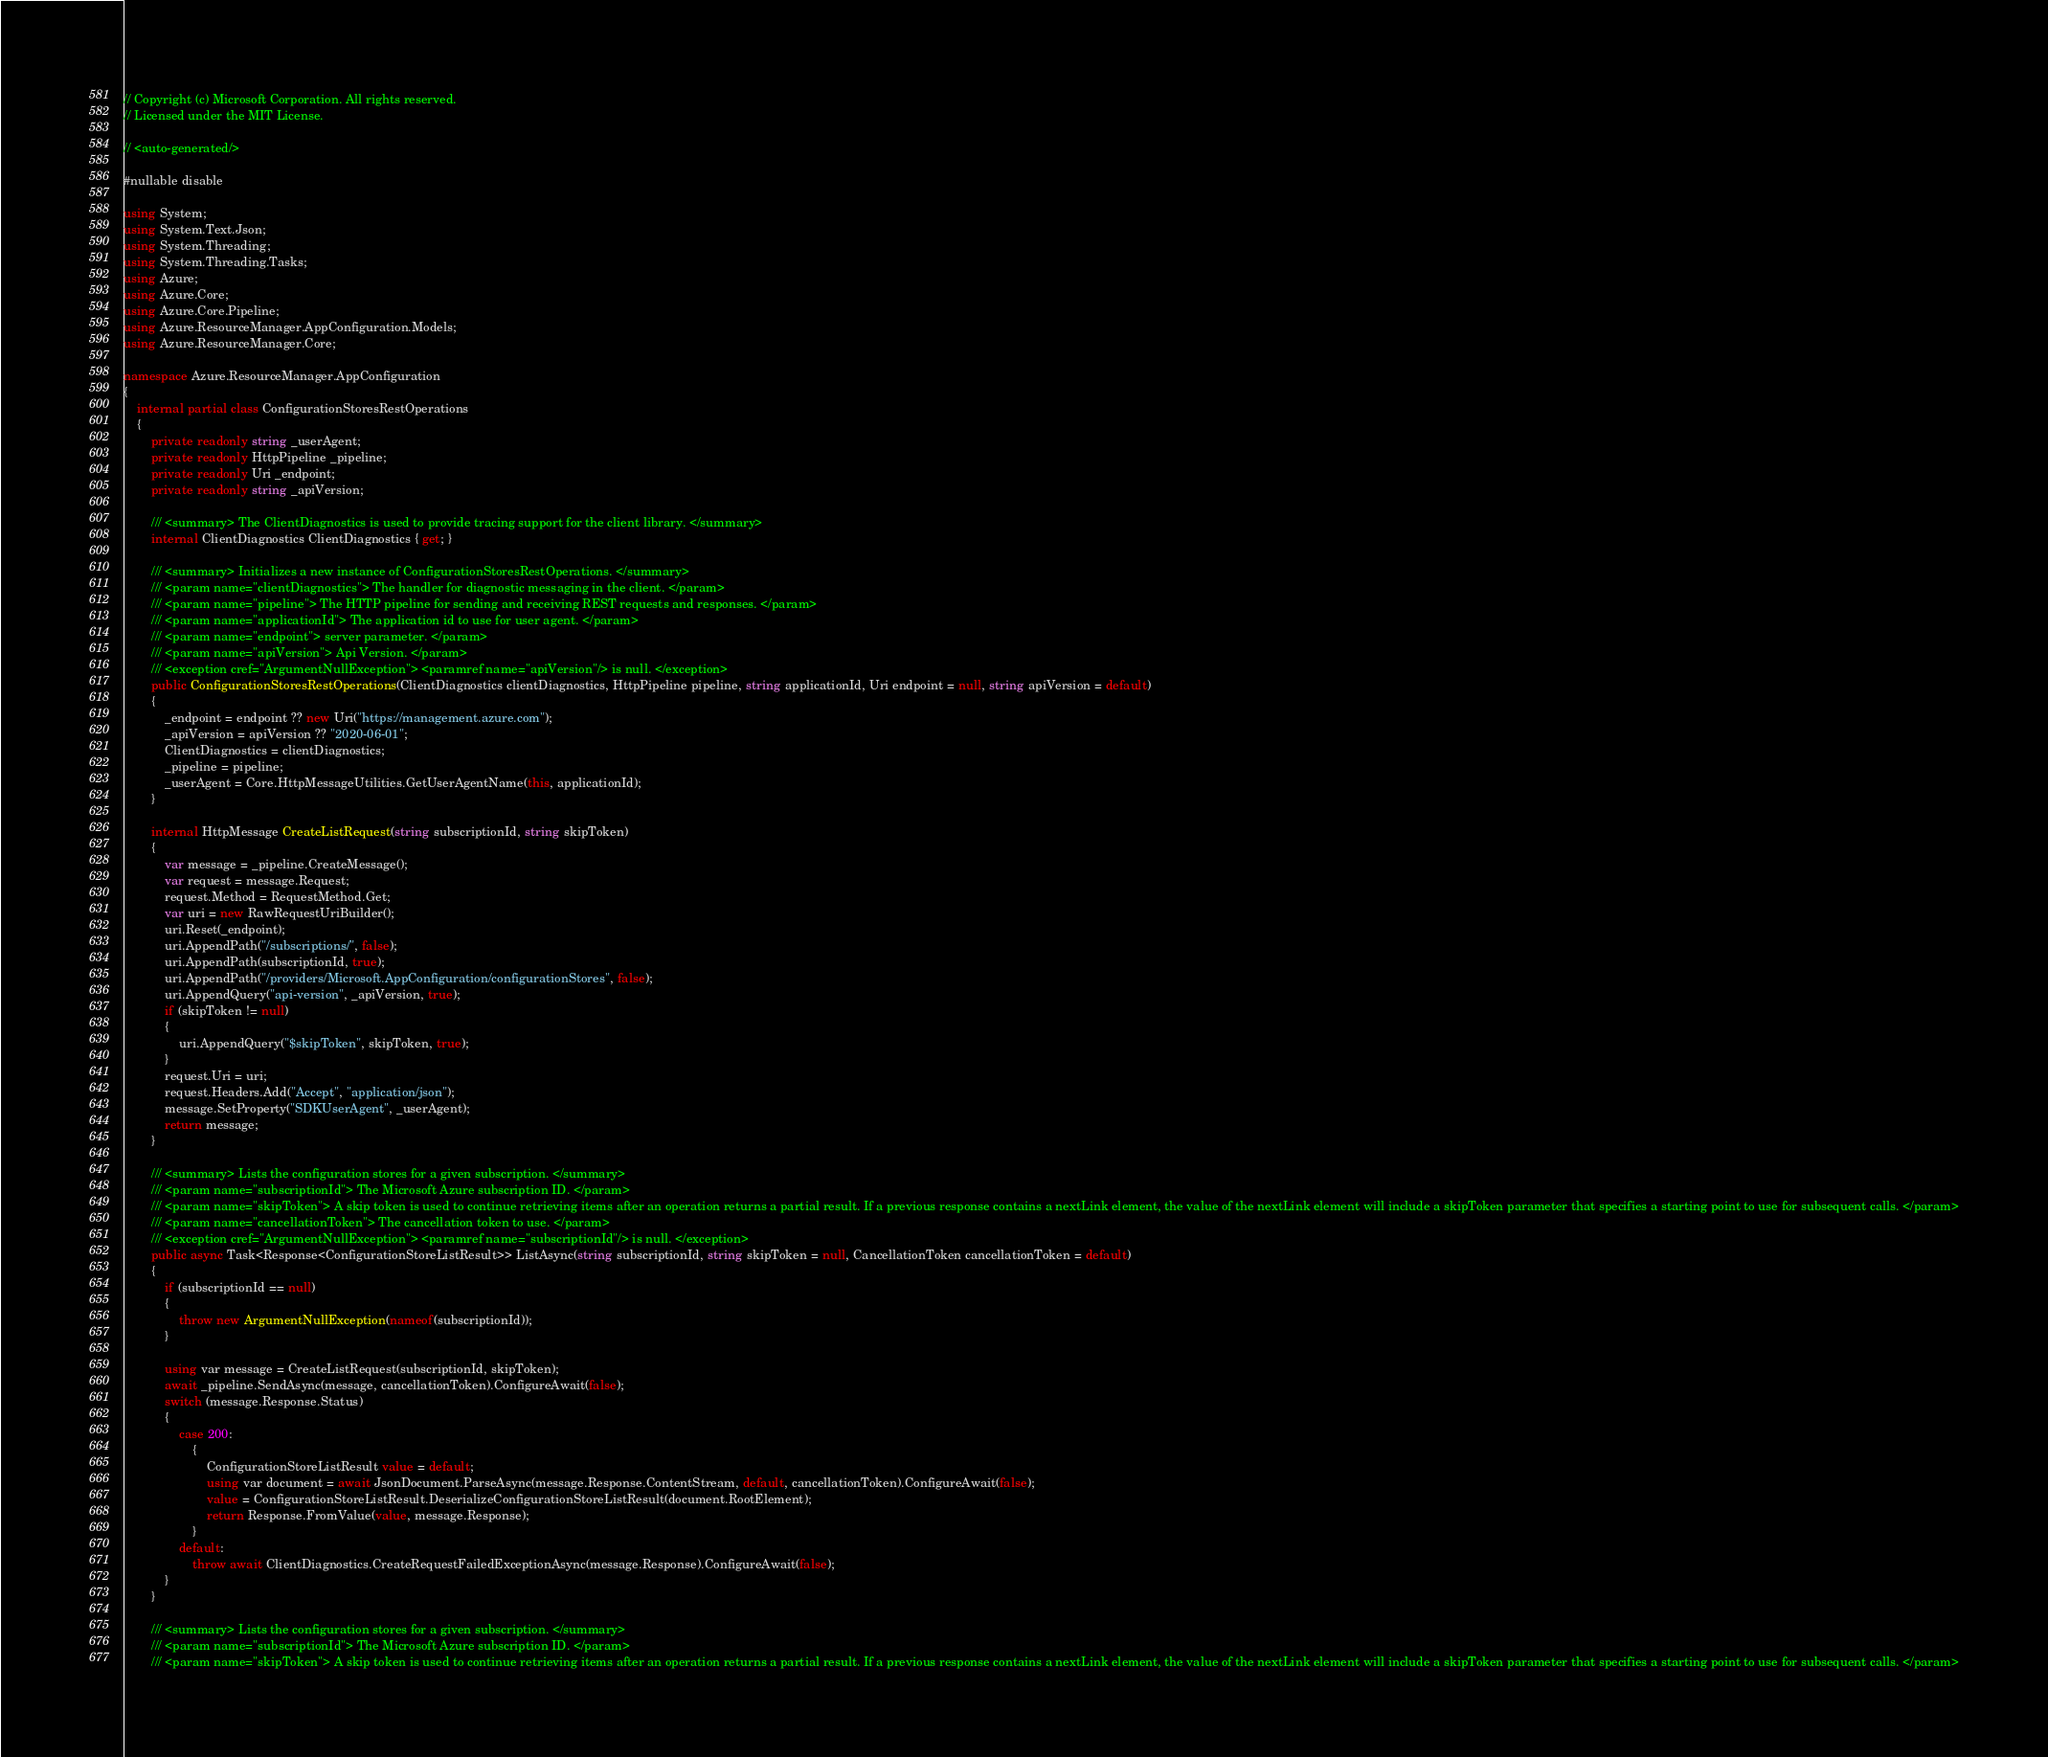<code> <loc_0><loc_0><loc_500><loc_500><_C#_>// Copyright (c) Microsoft Corporation. All rights reserved.
// Licensed under the MIT License.

// <auto-generated/>

#nullable disable

using System;
using System.Text.Json;
using System.Threading;
using System.Threading.Tasks;
using Azure;
using Azure.Core;
using Azure.Core.Pipeline;
using Azure.ResourceManager.AppConfiguration.Models;
using Azure.ResourceManager.Core;

namespace Azure.ResourceManager.AppConfiguration
{
    internal partial class ConfigurationStoresRestOperations
    {
        private readonly string _userAgent;
        private readonly HttpPipeline _pipeline;
        private readonly Uri _endpoint;
        private readonly string _apiVersion;

        /// <summary> The ClientDiagnostics is used to provide tracing support for the client library. </summary>
        internal ClientDiagnostics ClientDiagnostics { get; }

        /// <summary> Initializes a new instance of ConfigurationStoresRestOperations. </summary>
        /// <param name="clientDiagnostics"> The handler for diagnostic messaging in the client. </param>
        /// <param name="pipeline"> The HTTP pipeline for sending and receiving REST requests and responses. </param>
        /// <param name="applicationId"> The application id to use for user agent. </param>
        /// <param name="endpoint"> server parameter. </param>
        /// <param name="apiVersion"> Api Version. </param>
        /// <exception cref="ArgumentNullException"> <paramref name="apiVersion"/> is null. </exception>
        public ConfigurationStoresRestOperations(ClientDiagnostics clientDiagnostics, HttpPipeline pipeline, string applicationId, Uri endpoint = null, string apiVersion = default)
        {
            _endpoint = endpoint ?? new Uri("https://management.azure.com");
            _apiVersion = apiVersion ?? "2020-06-01";
            ClientDiagnostics = clientDiagnostics;
            _pipeline = pipeline;
            _userAgent = Core.HttpMessageUtilities.GetUserAgentName(this, applicationId);
        }

        internal HttpMessage CreateListRequest(string subscriptionId, string skipToken)
        {
            var message = _pipeline.CreateMessage();
            var request = message.Request;
            request.Method = RequestMethod.Get;
            var uri = new RawRequestUriBuilder();
            uri.Reset(_endpoint);
            uri.AppendPath("/subscriptions/", false);
            uri.AppendPath(subscriptionId, true);
            uri.AppendPath("/providers/Microsoft.AppConfiguration/configurationStores", false);
            uri.AppendQuery("api-version", _apiVersion, true);
            if (skipToken != null)
            {
                uri.AppendQuery("$skipToken", skipToken, true);
            }
            request.Uri = uri;
            request.Headers.Add("Accept", "application/json");
            message.SetProperty("SDKUserAgent", _userAgent);
            return message;
        }

        /// <summary> Lists the configuration stores for a given subscription. </summary>
        /// <param name="subscriptionId"> The Microsoft Azure subscription ID. </param>
        /// <param name="skipToken"> A skip token is used to continue retrieving items after an operation returns a partial result. If a previous response contains a nextLink element, the value of the nextLink element will include a skipToken parameter that specifies a starting point to use for subsequent calls. </param>
        /// <param name="cancellationToken"> The cancellation token to use. </param>
        /// <exception cref="ArgumentNullException"> <paramref name="subscriptionId"/> is null. </exception>
        public async Task<Response<ConfigurationStoreListResult>> ListAsync(string subscriptionId, string skipToken = null, CancellationToken cancellationToken = default)
        {
            if (subscriptionId == null)
            {
                throw new ArgumentNullException(nameof(subscriptionId));
            }

            using var message = CreateListRequest(subscriptionId, skipToken);
            await _pipeline.SendAsync(message, cancellationToken).ConfigureAwait(false);
            switch (message.Response.Status)
            {
                case 200:
                    {
                        ConfigurationStoreListResult value = default;
                        using var document = await JsonDocument.ParseAsync(message.Response.ContentStream, default, cancellationToken).ConfigureAwait(false);
                        value = ConfigurationStoreListResult.DeserializeConfigurationStoreListResult(document.RootElement);
                        return Response.FromValue(value, message.Response);
                    }
                default:
                    throw await ClientDiagnostics.CreateRequestFailedExceptionAsync(message.Response).ConfigureAwait(false);
            }
        }

        /// <summary> Lists the configuration stores for a given subscription. </summary>
        /// <param name="subscriptionId"> The Microsoft Azure subscription ID. </param>
        /// <param name="skipToken"> A skip token is used to continue retrieving items after an operation returns a partial result. If a previous response contains a nextLink element, the value of the nextLink element will include a skipToken parameter that specifies a starting point to use for subsequent calls. </param></code> 